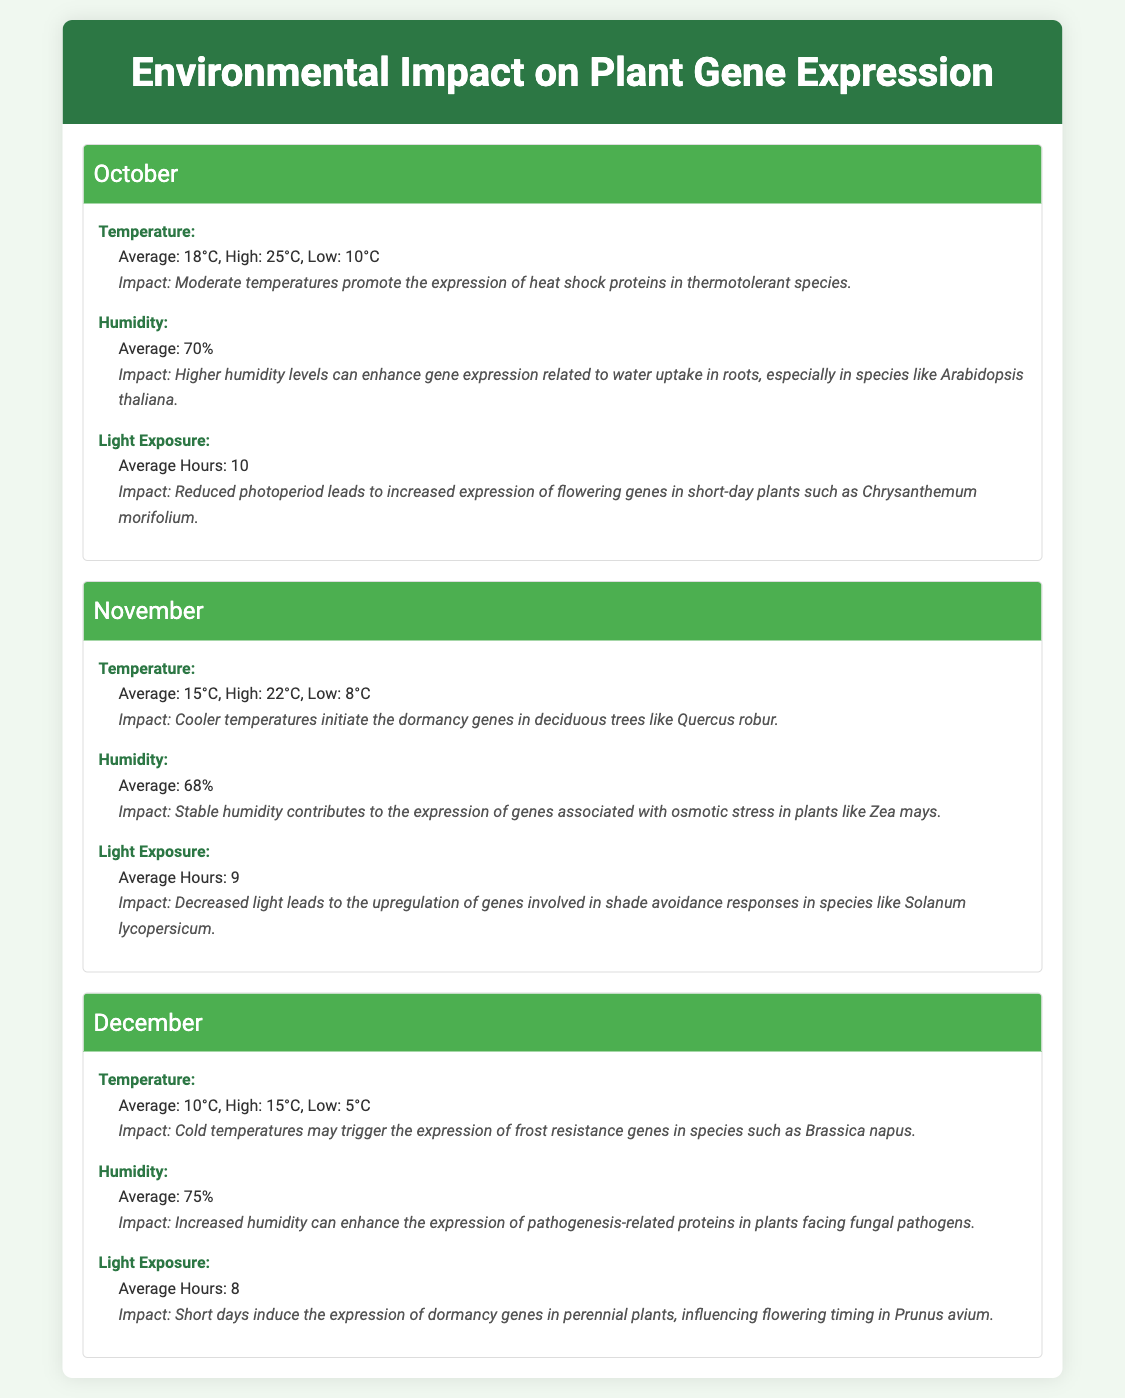What is the average temperature in October? The average temperature in October is stated in the document under the month section and is 18°C.
Answer: 18°C What is the highest humidity recorded in December? The document specifies the average humidity for December, which is 75%, as mentioned in the humidity section.
Answer: 75% Which plant species is associated with increased gene expression due to higher humidity in October? The impact portion of the humidity data in October mentions that higher humidity levels enhance gene expression related to water uptake in roots, specifically mentioning Arabidopsis thaliana.
Answer: Arabidopsis thaliana What is the average light exposure in November? The document provides the average hours of light exposure for November, which is found in the light exposure section.
Answer: 9 Which month has the lowest average temperature? The average temperatures for the months indicate that December has the lowest average temperature of 10°C.
Answer: December What is the impact of cooler temperatures mentioned for November? The impact section describes that cooler temperatures initiate dormancy genes in trees, specifically noting Quercus robur, thus combining temperature and species in the reasoning.
Answer: Dormancy genes in Quercus robur How many hours of light exposure are recorded for October? The document states the average hours of light exposure for October in the corresponding section, which is noted as 10 hours.
Answer: 10 What environmental factor affects flowering genes in short-day plants in October? The light exposure impact mentions that reduced photoperiod leads to increased expression of flowering genes in short-day plants.
Answer: Reduced photoperiod Which month shows an increase in humidity leading to pathogenesis-related proteins? The document describes increased humidity enhancing the expression of certain proteins, specifically in the December section.
Answer: December 